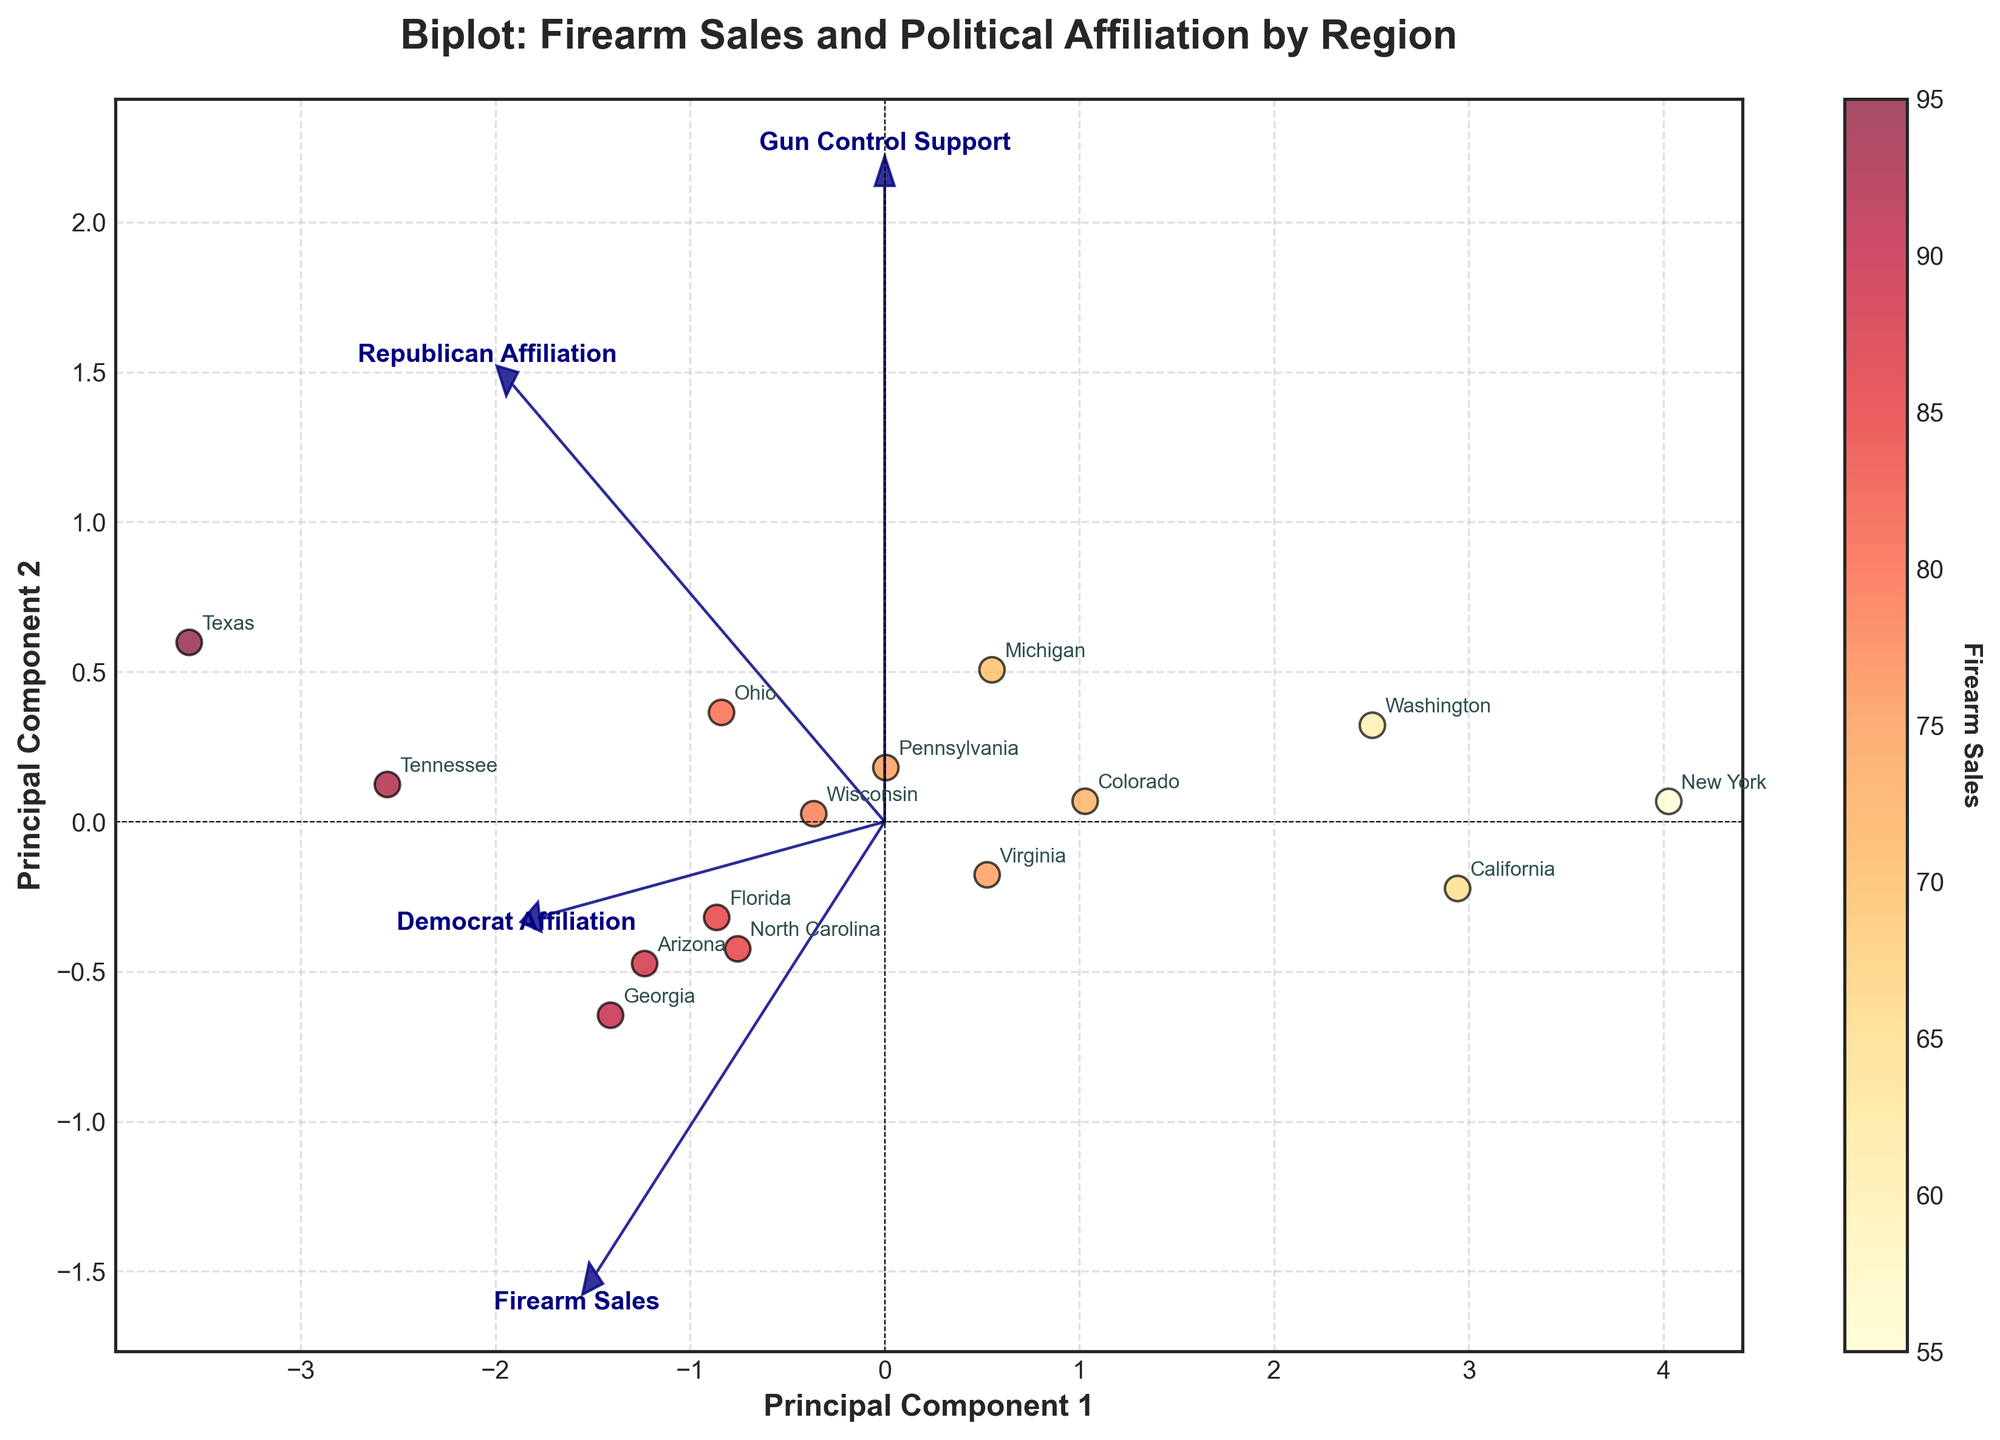How many principal components are shown in the biplot? The biplot shows two principal components, as indicated by the x and y axes labeled "Principal Component 1" and "Principal Component 2."
Answer: Two Which region has the highest firearm sales according to the biplot? The region with the highest firearm sales can be identified by looking at the color intensity on the scatter plot. The regions with darker/redder points indicate higher firearm sales. Texas is the region with the darkest color in the figure.
Answer: Texas Which feature vector is closest to the horizontal axis? The feature vector closest to the horizontal axis is the one with the smallest projection on the vertical axis. In the figure, the "Firearm Sales" vector is closest to the horizontal axis.
Answer: Firearm Sales Do regions with higher Republican affiliation seem to correlate with higher firearm sales? By examining the arrows for "Republican Affiliation" and "Firearm Sales," we notice that they point generally in the same direction. This suggests a positive correlation between higher Republican affiliation and higher firearm sales.
Answer: Yes How does the "Gun Control Support" feature vector relate to "Firearm Sales"? The "Gun Control Support" vector points in an opposite direction to the "Firearm Sales" vector. This suggests that there is a negative correlation between support for gun control and firearm sales.
Answer: Negatively correlated Name two regions that have an approximately similar mix of Democrat and Republican affiliation. Regions with similar projections on the Democrat and Republican vectors are approximately equally mixed. Wisconsin and North Carolina appear to have similar projection lengths on both vectors.
Answer: Wisconsin and North Carolina What general conclusion can you draw about regions with high firearm sales in relation to "Gun Control Support"? Regions with high firearm sales generally have lower projections on the "Gun Control Support" vector, as the two vectors point in opposite directions. This implies that regions with high firearm sales tend to have lower support for gun control.
Answer: Lower support for gun control Are there any regions that are outliers with respect to both principal components? Outliers can be identified as points that are farthest from the center of the plot. Texas, with its high firearm sales, stands out as it is farthest along Principal Component 1 and 2.
Answer: Texas Is there a region with both high Democrat affiliation and high gun control support? To find a region with high Democrat affiliation and high gun control support, look for points that are aligned both with the "Democrat Affiliation" and "Gun Control Support" vectors. New York stands out as such a region.
Answer: New York 